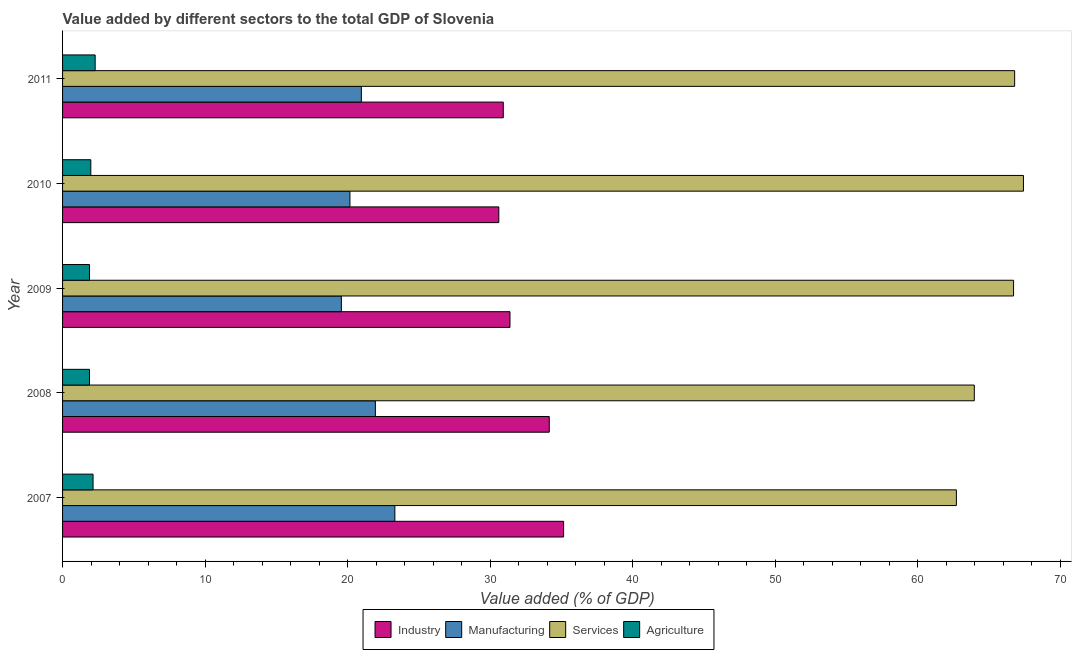How many different coloured bars are there?
Keep it short and to the point. 4. Are the number of bars per tick equal to the number of legend labels?
Your answer should be compact. Yes. Are the number of bars on each tick of the Y-axis equal?
Give a very brief answer. Yes. What is the label of the 4th group of bars from the top?
Ensure brevity in your answer.  2008. In how many cases, is the number of bars for a given year not equal to the number of legend labels?
Make the answer very short. 0. What is the value added by agricultural sector in 2007?
Offer a terse response. 2.14. Across all years, what is the maximum value added by industrial sector?
Your answer should be compact. 35.15. Across all years, what is the minimum value added by industrial sector?
Ensure brevity in your answer.  30.61. What is the total value added by manufacturing sector in the graph?
Keep it short and to the point. 105.94. What is the difference between the value added by agricultural sector in 2009 and that in 2011?
Make the answer very short. -0.39. What is the difference between the value added by industrial sector in 2008 and the value added by manufacturing sector in 2011?
Your response must be concise. 13.18. What is the average value added by manufacturing sector per year?
Offer a terse response. 21.19. In the year 2007, what is the difference between the value added by manufacturing sector and value added by services sector?
Offer a terse response. -39.4. In how many years, is the value added by agricultural sector greater than 14 %?
Your answer should be very brief. 0. What is the ratio of the value added by agricultural sector in 2010 to that in 2011?
Provide a short and direct response. 0.87. Is the value added by manufacturing sector in 2007 less than that in 2008?
Provide a succinct answer. No. Is the difference between the value added by services sector in 2008 and 2010 greater than the difference between the value added by industrial sector in 2008 and 2010?
Make the answer very short. No. In how many years, is the value added by agricultural sector greater than the average value added by agricultural sector taken over all years?
Offer a terse response. 2. Is it the case that in every year, the sum of the value added by agricultural sector and value added by manufacturing sector is greater than the sum of value added by services sector and value added by industrial sector?
Your response must be concise. No. What does the 4th bar from the top in 2011 represents?
Make the answer very short. Industry. What does the 4th bar from the bottom in 2011 represents?
Provide a short and direct response. Agriculture. Is it the case that in every year, the sum of the value added by industrial sector and value added by manufacturing sector is greater than the value added by services sector?
Provide a short and direct response. No. How many bars are there?
Offer a very short reply. 20. Are all the bars in the graph horizontal?
Give a very brief answer. Yes. How many years are there in the graph?
Your response must be concise. 5. Does the graph contain grids?
Your answer should be very brief. No. Where does the legend appear in the graph?
Provide a succinct answer. Bottom center. What is the title of the graph?
Keep it short and to the point. Value added by different sectors to the total GDP of Slovenia. What is the label or title of the X-axis?
Offer a terse response. Value added (% of GDP). What is the label or title of the Y-axis?
Offer a terse response. Year. What is the Value added (% of GDP) in Industry in 2007?
Your answer should be very brief. 35.15. What is the Value added (% of GDP) in Manufacturing in 2007?
Ensure brevity in your answer.  23.31. What is the Value added (% of GDP) in Services in 2007?
Provide a succinct answer. 62.71. What is the Value added (% of GDP) of Agriculture in 2007?
Ensure brevity in your answer.  2.14. What is the Value added (% of GDP) in Industry in 2008?
Your answer should be very brief. 34.15. What is the Value added (% of GDP) in Manufacturing in 2008?
Provide a short and direct response. 21.95. What is the Value added (% of GDP) in Services in 2008?
Give a very brief answer. 63.96. What is the Value added (% of GDP) of Agriculture in 2008?
Offer a terse response. 1.89. What is the Value added (% of GDP) of Industry in 2009?
Provide a succinct answer. 31.39. What is the Value added (% of GDP) of Manufacturing in 2009?
Your response must be concise. 19.56. What is the Value added (% of GDP) in Services in 2009?
Your answer should be very brief. 66.72. What is the Value added (% of GDP) in Agriculture in 2009?
Your answer should be compact. 1.89. What is the Value added (% of GDP) in Industry in 2010?
Your response must be concise. 30.61. What is the Value added (% of GDP) of Manufacturing in 2010?
Provide a succinct answer. 20.16. What is the Value added (% of GDP) in Services in 2010?
Keep it short and to the point. 67.41. What is the Value added (% of GDP) in Agriculture in 2010?
Ensure brevity in your answer.  1.98. What is the Value added (% of GDP) in Industry in 2011?
Ensure brevity in your answer.  30.92. What is the Value added (% of GDP) in Manufacturing in 2011?
Ensure brevity in your answer.  20.96. What is the Value added (% of GDP) of Services in 2011?
Provide a succinct answer. 66.79. What is the Value added (% of GDP) of Agriculture in 2011?
Your answer should be compact. 2.29. Across all years, what is the maximum Value added (% of GDP) in Industry?
Your answer should be very brief. 35.15. Across all years, what is the maximum Value added (% of GDP) of Manufacturing?
Your answer should be compact. 23.31. Across all years, what is the maximum Value added (% of GDP) in Services?
Make the answer very short. 67.41. Across all years, what is the maximum Value added (% of GDP) of Agriculture?
Ensure brevity in your answer.  2.29. Across all years, what is the minimum Value added (% of GDP) of Industry?
Provide a succinct answer. 30.61. Across all years, what is the minimum Value added (% of GDP) of Manufacturing?
Offer a terse response. 19.56. Across all years, what is the minimum Value added (% of GDP) of Services?
Ensure brevity in your answer.  62.71. Across all years, what is the minimum Value added (% of GDP) in Agriculture?
Ensure brevity in your answer.  1.89. What is the total Value added (% of GDP) of Industry in the graph?
Your answer should be very brief. 162.21. What is the total Value added (% of GDP) of Manufacturing in the graph?
Provide a succinct answer. 105.94. What is the total Value added (% of GDP) of Services in the graph?
Your answer should be very brief. 327.6. What is the total Value added (% of GDP) in Agriculture in the graph?
Your answer should be very brief. 10.19. What is the difference between the Value added (% of GDP) of Manufacturing in 2007 and that in 2008?
Offer a very short reply. 1.37. What is the difference between the Value added (% of GDP) of Services in 2007 and that in 2008?
Offer a terse response. -1.26. What is the difference between the Value added (% of GDP) of Agriculture in 2007 and that in 2008?
Offer a terse response. 0.25. What is the difference between the Value added (% of GDP) of Industry in 2007 and that in 2009?
Your answer should be very brief. 3.76. What is the difference between the Value added (% of GDP) of Manufacturing in 2007 and that in 2009?
Your answer should be very brief. 3.75. What is the difference between the Value added (% of GDP) in Services in 2007 and that in 2009?
Your response must be concise. -4.01. What is the difference between the Value added (% of GDP) in Agriculture in 2007 and that in 2009?
Offer a very short reply. 0.25. What is the difference between the Value added (% of GDP) in Industry in 2007 and that in 2010?
Ensure brevity in your answer.  4.55. What is the difference between the Value added (% of GDP) of Manufacturing in 2007 and that in 2010?
Offer a very short reply. 3.15. What is the difference between the Value added (% of GDP) of Services in 2007 and that in 2010?
Offer a very short reply. -4.7. What is the difference between the Value added (% of GDP) in Agriculture in 2007 and that in 2010?
Your answer should be very brief. 0.16. What is the difference between the Value added (% of GDP) of Industry in 2007 and that in 2011?
Your answer should be very brief. 4.23. What is the difference between the Value added (% of GDP) in Manufacturing in 2007 and that in 2011?
Keep it short and to the point. 2.35. What is the difference between the Value added (% of GDP) of Services in 2007 and that in 2011?
Ensure brevity in your answer.  -4.09. What is the difference between the Value added (% of GDP) in Agriculture in 2007 and that in 2011?
Your answer should be very brief. -0.15. What is the difference between the Value added (% of GDP) in Industry in 2008 and that in 2009?
Your answer should be very brief. 2.76. What is the difference between the Value added (% of GDP) of Manufacturing in 2008 and that in 2009?
Give a very brief answer. 2.39. What is the difference between the Value added (% of GDP) of Services in 2008 and that in 2009?
Offer a very short reply. -2.75. What is the difference between the Value added (% of GDP) of Agriculture in 2008 and that in 2009?
Your answer should be compact. -0. What is the difference between the Value added (% of GDP) in Industry in 2008 and that in 2010?
Your answer should be very brief. 3.54. What is the difference between the Value added (% of GDP) of Manufacturing in 2008 and that in 2010?
Provide a succinct answer. 1.78. What is the difference between the Value added (% of GDP) in Services in 2008 and that in 2010?
Give a very brief answer. -3.45. What is the difference between the Value added (% of GDP) of Agriculture in 2008 and that in 2010?
Give a very brief answer. -0.09. What is the difference between the Value added (% of GDP) in Industry in 2008 and that in 2011?
Your response must be concise. 3.23. What is the difference between the Value added (% of GDP) of Manufacturing in 2008 and that in 2011?
Ensure brevity in your answer.  0.98. What is the difference between the Value added (% of GDP) in Services in 2008 and that in 2011?
Give a very brief answer. -2.83. What is the difference between the Value added (% of GDP) in Agriculture in 2008 and that in 2011?
Your answer should be compact. -0.4. What is the difference between the Value added (% of GDP) in Industry in 2009 and that in 2010?
Keep it short and to the point. 0.78. What is the difference between the Value added (% of GDP) in Manufacturing in 2009 and that in 2010?
Provide a short and direct response. -0.6. What is the difference between the Value added (% of GDP) in Services in 2009 and that in 2010?
Ensure brevity in your answer.  -0.69. What is the difference between the Value added (% of GDP) of Agriculture in 2009 and that in 2010?
Ensure brevity in your answer.  -0.09. What is the difference between the Value added (% of GDP) in Industry in 2009 and that in 2011?
Offer a very short reply. 0.47. What is the difference between the Value added (% of GDP) in Manufacturing in 2009 and that in 2011?
Make the answer very short. -1.4. What is the difference between the Value added (% of GDP) of Services in 2009 and that in 2011?
Your answer should be compact. -0.08. What is the difference between the Value added (% of GDP) of Agriculture in 2009 and that in 2011?
Your answer should be compact. -0.39. What is the difference between the Value added (% of GDP) in Industry in 2010 and that in 2011?
Your answer should be compact. -0.31. What is the difference between the Value added (% of GDP) in Manufacturing in 2010 and that in 2011?
Offer a very short reply. -0.8. What is the difference between the Value added (% of GDP) in Services in 2010 and that in 2011?
Your answer should be very brief. 0.62. What is the difference between the Value added (% of GDP) of Agriculture in 2010 and that in 2011?
Your answer should be very brief. -0.3. What is the difference between the Value added (% of GDP) of Industry in 2007 and the Value added (% of GDP) of Manufacturing in 2008?
Your response must be concise. 13.21. What is the difference between the Value added (% of GDP) of Industry in 2007 and the Value added (% of GDP) of Services in 2008?
Make the answer very short. -28.81. What is the difference between the Value added (% of GDP) in Industry in 2007 and the Value added (% of GDP) in Agriculture in 2008?
Keep it short and to the point. 33.26. What is the difference between the Value added (% of GDP) of Manufacturing in 2007 and the Value added (% of GDP) of Services in 2008?
Offer a very short reply. -40.65. What is the difference between the Value added (% of GDP) in Manufacturing in 2007 and the Value added (% of GDP) in Agriculture in 2008?
Ensure brevity in your answer.  21.42. What is the difference between the Value added (% of GDP) in Services in 2007 and the Value added (% of GDP) in Agriculture in 2008?
Offer a terse response. 60.82. What is the difference between the Value added (% of GDP) in Industry in 2007 and the Value added (% of GDP) in Manufacturing in 2009?
Make the answer very short. 15.59. What is the difference between the Value added (% of GDP) in Industry in 2007 and the Value added (% of GDP) in Services in 2009?
Your response must be concise. -31.57. What is the difference between the Value added (% of GDP) in Industry in 2007 and the Value added (% of GDP) in Agriculture in 2009?
Make the answer very short. 33.26. What is the difference between the Value added (% of GDP) of Manufacturing in 2007 and the Value added (% of GDP) of Services in 2009?
Offer a very short reply. -43.41. What is the difference between the Value added (% of GDP) in Manufacturing in 2007 and the Value added (% of GDP) in Agriculture in 2009?
Offer a terse response. 21.42. What is the difference between the Value added (% of GDP) in Services in 2007 and the Value added (% of GDP) in Agriculture in 2009?
Offer a very short reply. 60.82. What is the difference between the Value added (% of GDP) of Industry in 2007 and the Value added (% of GDP) of Manufacturing in 2010?
Provide a short and direct response. 14.99. What is the difference between the Value added (% of GDP) in Industry in 2007 and the Value added (% of GDP) in Services in 2010?
Offer a terse response. -32.26. What is the difference between the Value added (% of GDP) of Industry in 2007 and the Value added (% of GDP) of Agriculture in 2010?
Offer a very short reply. 33.17. What is the difference between the Value added (% of GDP) in Manufacturing in 2007 and the Value added (% of GDP) in Services in 2010?
Your response must be concise. -44.1. What is the difference between the Value added (% of GDP) in Manufacturing in 2007 and the Value added (% of GDP) in Agriculture in 2010?
Provide a succinct answer. 21.33. What is the difference between the Value added (% of GDP) in Services in 2007 and the Value added (% of GDP) in Agriculture in 2010?
Offer a very short reply. 60.73. What is the difference between the Value added (% of GDP) in Industry in 2007 and the Value added (% of GDP) in Manufacturing in 2011?
Offer a terse response. 14.19. What is the difference between the Value added (% of GDP) of Industry in 2007 and the Value added (% of GDP) of Services in 2011?
Keep it short and to the point. -31.64. What is the difference between the Value added (% of GDP) in Industry in 2007 and the Value added (% of GDP) in Agriculture in 2011?
Your response must be concise. 32.87. What is the difference between the Value added (% of GDP) of Manufacturing in 2007 and the Value added (% of GDP) of Services in 2011?
Make the answer very short. -43.48. What is the difference between the Value added (% of GDP) of Manufacturing in 2007 and the Value added (% of GDP) of Agriculture in 2011?
Keep it short and to the point. 21.03. What is the difference between the Value added (% of GDP) in Services in 2007 and the Value added (% of GDP) in Agriculture in 2011?
Keep it short and to the point. 60.42. What is the difference between the Value added (% of GDP) in Industry in 2008 and the Value added (% of GDP) in Manufacturing in 2009?
Give a very brief answer. 14.59. What is the difference between the Value added (% of GDP) in Industry in 2008 and the Value added (% of GDP) in Services in 2009?
Your answer should be very brief. -32.57. What is the difference between the Value added (% of GDP) of Industry in 2008 and the Value added (% of GDP) of Agriculture in 2009?
Provide a succinct answer. 32.25. What is the difference between the Value added (% of GDP) in Manufacturing in 2008 and the Value added (% of GDP) in Services in 2009?
Provide a short and direct response. -44.77. What is the difference between the Value added (% of GDP) in Manufacturing in 2008 and the Value added (% of GDP) in Agriculture in 2009?
Keep it short and to the point. 20.05. What is the difference between the Value added (% of GDP) in Services in 2008 and the Value added (% of GDP) in Agriculture in 2009?
Keep it short and to the point. 62.07. What is the difference between the Value added (% of GDP) of Industry in 2008 and the Value added (% of GDP) of Manufacturing in 2010?
Offer a very short reply. 13.98. What is the difference between the Value added (% of GDP) of Industry in 2008 and the Value added (% of GDP) of Services in 2010?
Your answer should be compact. -33.27. What is the difference between the Value added (% of GDP) of Industry in 2008 and the Value added (% of GDP) of Agriculture in 2010?
Provide a short and direct response. 32.16. What is the difference between the Value added (% of GDP) of Manufacturing in 2008 and the Value added (% of GDP) of Services in 2010?
Keep it short and to the point. -45.47. What is the difference between the Value added (% of GDP) in Manufacturing in 2008 and the Value added (% of GDP) in Agriculture in 2010?
Provide a short and direct response. 19.96. What is the difference between the Value added (% of GDP) in Services in 2008 and the Value added (% of GDP) in Agriculture in 2010?
Ensure brevity in your answer.  61.98. What is the difference between the Value added (% of GDP) of Industry in 2008 and the Value added (% of GDP) of Manufacturing in 2011?
Offer a very short reply. 13.18. What is the difference between the Value added (% of GDP) of Industry in 2008 and the Value added (% of GDP) of Services in 2011?
Offer a terse response. -32.65. What is the difference between the Value added (% of GDP) of Industry in 2008 and the Value added (% of GDP) of Agriculture in 2011?
Your answer should be compact. 31.86. What is the difference between the Value added (% of GDP) of Manufacturing in 2008 and the Value added (% of GDP) of Services in 2011?
Keep it short and to the point. -44.85. What is the difference between the Value added (% of GDP) of Manufacturing in 2008 and the Value added (% of GDP) of Agriculture in 2011?
Offer a terse response. 19.66. What is the difference between the Value added (% of GDP) in Services in 2008 and the Value added (% of GDP) in Agriculture in 2011?
Offer a very short reply. 61.68. What is the difference between the Value added (% of GDP) of Industry in 2009 and the Value added (% of GDP) of Manufacturing in 2010?
Provide a succinct answer. 11.23. What is the difference between the Value added (% of GDP) in Industry in 2009 and the Value added (% of GDP) in Services in 2010?
Offer a very short reply. -36.02. What is the difference between the Value added (% of GDP) in Industry in 2009 and the Value added (% of GDP) in Agriculture in 2010?
Make the answer very short. 29.41. What is the difference between the Value added (% of GDP) in Manufacturing in 2009 and the Value added (% of GDP) in Services in 2010?
Your answer should be compact. -47.85. What is the difference between the Value added (% of GDP) of Manufacturing in 2009 and the Value added (% of GDP) of Agriculture in 2010?
Offer a terse response. 17.58. What is the difference between the Value added (% of GDP) of Services in 2009 and the Value added (% of GDP) of Agriculture in 2010?
Offer a terse response. 64.74. What is the difference between the Value added (% of GDP) of Industry in 2009 and the Value added (% of GDP) of Manufacturing in 2011?
Provide a succinct answer. 10.43. What is the difference between the Value added (% of GDP) of Industry in 2009 and the Value added (% of GDP) of Services in 2011?
Your answer should be very brief. -35.41. What is the difference between the Value added (% of GDP) in Industry in 2009 and the Value added (% of GDP) in Agriculture in 2011?
Give a very brief answer. 29.1. What is the difference between the Value added (% of GDP) of Manufacturing in 2009 and the Value added (% of GDP) of Services in 2011?
Provide a short and direct response. -47.23. What is the difference between the Value added (% of GDP) of Manufacturing in 2009 and the Value added (% of GDP) of Agriculture in 2011?
Your answer should be very brief. 17.27. What is the difference between the Value added (% of GDP) of Services in 2009 and the Value added (% of GDP) of Agriculture in 2011?
Provide a short and direct response. 64.43. What is the difference between the Value added (% of GDP) in Industry in 2010 and the Value added (% of GDP) in Manufacturing in 2011?
Provide a short and direct response. 9.64. What is the difference between the Value added (% of GDP) of Industry in 2010 and the Value added (% of GDP) of Services in 2011?
Give a very brief answer. -36.19. What is the difference between the Value added (% of GDP) in Industry in 2010 and the Value added (% of GDP) in Agriculture in 2011?
Your answer should be very brief. 28.32. What is the difference between the Value added (% of GDP) of Manufacturing in 2010 and the Value added (% of GDP) of Services in 2011?
Offer a terse response. -46.63. What is the difference between the Value added (% of GDP) of Manufacturing in 2010 and the Value added (% of GDP) of Agriculture in 2011?
Your response must be concise. 17.87. What is the difference between the Value added (% of GDP) of Services in 2010 and the Value added (% of GDP) of Agriculture in 2011?
Your answer should be very brief. 65.13. What is the average Value added (% of GDP) in Industry per year?
Provide a succinct answer. 32.44. What is the average Value added (% of GDP) of Manufacturing per year?
Your answer should be very brief. 21.19. What is the average Value added (% of GDP) of Services per year?
Your answer should be compact. 65.52. What is the average Value added (% of GDP) in Agriculture per year?
Keep it short and to the point. 2.04. In the year 2007, what is the difference between the Value added (% of GDP) of Industry and Value added (% of GDP) of Manufacturing?
Provide a short and direct response. 11.84. In the year 2007, what is the difference between the Value added (% of GDP) of Industry and Value added (% of GDP) of Services?
Provide a succinct answer. -27.56. In the year 2007, what is the difference between the Value added (% of GDP) of Industry and Value added (% of GDP) of Agriculture?
Provide a short and direct response. 33.01. In the year 2007, what is the difference between the Value added (% of GDP) of Manufacturing and Value added (% of GDP) of Services?
Your response must be concise. -39.4. In the year 2007, what is the difference between the Value added (% of GDP) of Manufacturing and Value added (% of GDP) of Agriculture?
Your answer should be compact. 21.17. In the year 2007, what is the difference between the Value added (% of GDP) of Services and Value added (% of GDP) of Agriculture?
Keep it short and to the point. 60.57. In the year 2008, what is the difference between the Value added (% of GDP) of Industry and Value added (% of GDP) of Manufacturing?
Keep it short and to the point. 12.2. In the year 2008, what is the difference between the Value added (% of GDP) in Industry and Value added (% of GDP) in Services?
Make the answer very short. -29.82. In the year 2008, what is the difference between the Value added (% of GDP) in Industry and Value added (% of GDP) in Agriculture?
Provide a succinct answer. 32.26. In the year 2008, what is the difference between the Value added (% of GDP) in Manufacturing and Value added (% of GDP) in Services?
Provide a succinct answer. -42.02. In the year 2008, what is the difference between the Value added (% of GDP) in Manufacturing and Value added (% of GDP) in Agriculture?
Keep it short and to the point. 20.06. In the year 2008, what is the difference between the Value added (% of GDP) of Services and Value added (% of GDP) of Agriculture?
Your response must be concise. 62.07. In the year 2009, what is the difference between the Value added (% of GDP) of Industry and Value added (% of GDP) of Manufacturing?
Your response must be concise. 11.83. In the year 2009, what is the difference between the Value added (% of GDP) of Industry and Value added (% of GDP) of Services?
Ensure brevity in your answer.  -35.33. In the year 2009, what is the difference between the Value added (% of GDP) of Industry and Value added (% of GDP) of Agriculture?
Keep it short and to the point. 29.5. In the year 2009, what is the difference between the Value added (% of GDP) in Manufacturing and Value added (% of GDP) in Services?
Give a very brief answer. -47.16. In the year 2009, what is the difference between the Value added (% of GDP) of Manufacturing and Value added (% of GDP) of Agriculture?
Your answer should be very brief. 17.67. In the year 2009, what is the difference between the Value added (% of GDP) of Services and Value added (% of GDP) of Agriculture?
Keep it short and to the point. 64.83. In the year 2010, what is the difference between the Value added (% of GDP) of Industry and Value added (% of GDP) of Manufacturing?
Your answer should be very brief. 10.44. In the year 2010, what is the difference between the Value added (% of GDP) in Industry and Value added (% of GDP) in Services?
Your response must be concise. -36.81. In the year 2010, what is the difference between the Value added (% of GDP) of Industry and Value added (% of GDP) of Agriculture?
Provide a succinct answer. 28.62. In the year 2010, what is the difference between the Value added (% of GDP) in Manufacturing and Value added (% of GDP) in Services?
Your answer should be very brief. -47.25. In the year 2010, what is the difference between the Value added (% of GDP) in Manufacturing and Value added (% of GDP) in Agriculture?
Your answer should be very brief. 18.18. In the year 2010, what is the difference between the Value added (% of GDP) in Services and Value added (% of GDP) in Agriculture?
Provide a short and direct response. 65.43. In the year 2011, what is the difference between the Value added (% of GDP) in Industry and Value added (% of GDP) in Manufacturing?
Provide a short and direct response. 9.96. In the year 2011, what is the difference between the Value added (% of GDP) of Industry and Value added (% of GDP) of Services?
Offer a terse response. -35.87. In the year 2011, what is the difference between the Value added (% of GDP) of Industry and Value added (% of GDP) of Agriculture?
Your answer should be very brief. 28.63. In the year 2011, what is the difference between the Value added (% of GDP) in Manufacturing and Value added (% of GDP) in Services?
Ensure brevity in your answer.  -45.83. In the year 2011, what is the difference between the Value added (% of GDP) in Manufacturing and Value added (% of GDP) in Agriculture?
Your answer should be compact. 18.68. In the year 2011, what is the difference between the Value added (% of GDP) in Services and Value added (% of GDP) in Agriculture?
Give a very brief answer. 64.51. What is the ratio of the Value added (% of GDP) of Industry in 2007 to that in 2008?
Your response must be concise. 1.03. What is the ratio of the Value added (% of GDP) in Manufacturing in 2007 to that in 2008?
Ensure brevity in your answer.  1.06. What is the ratio of the Value added (% of GDP) in Services in 2007 to that in 2008?
Keep it short and to the point. 0.98. What is the ratio of the Value added (% of GDP) in Agriculture in 2007 to that in 2008?
Ensure brevity in your answer.  1.13. What is the ratio of the Value added (% of GDP) in Industry in 2007 to that in 2009?
Provide a short and direct response. 1.12. What is the ratio of the Value added (% of GDP) in Manufacturing in 2007 to that in 2009?
Provide a short and direct response. 1.19. What is the ratio of the Value added (% of GDP) in Services in 2007 to that in 2009?
Your response must be concise. 0.94. What is the ratio of the Value added (% of GDP) in Agriculture in 2007 to that in 2009?
Your answer should be compact. 1.13. What is the ratio of the Value added (% of GDP) in Industry in 2007 to that in 2010?
Provide a short and direct response. 1.15. What is the ratio of the Value added (% of GDP) of Manufacturing in 2007 to that in 2010?
Make the answer very short. 1.16. What is the ratio of the Value added (% of GDP) of Services in 2007 to that in 2010?
Provide a short and direct response. 0.93. What is the ratio of the Value added (% of GDP) of Agriculture in 2007 to that in 2010?
Your response must be concise. 1.08. What is the ratio of the Value added (% of GDP) of Industry in 2007 to that in 2011?
Ensure brevity in your answer.  1.14. What is the ratio of the Value added (% of GDP) in Manufacturing in 2007 to that in 2011?
Give a very brief answer. 1.11. What is the ratio of the Value added (% of GDP) in Services in 2007 to that in 2011?
Your answer should be very brief. 0.94. What is the ratio of the Value added (% of GDP) of Agriculture in 2007 to that in 2011?
Offer a very short reply. 0.94. What is the ratio of the Value added (% of GDP) in Industry in 2008 to that in 2009?
Make the answer very short. 1.09. What is the ratio of the Value added (% of GDP) of Manufacturing in 2008 to that in 2009?
Give a very brief answer. 1.12. What is the ratio of the Value added (% of GDP) of Services in 2008 to that in 2009?
Your response must be concise. 0.96. What is the ratio of the Value added (% of GDP) of Industry in 2008 to that in 2010?
Offer a terse response. 1.12. What is the ratio of the Value added (% of GDP) of Manufacturing in 2008 to that in 2010?
Your response must be concise. 1.09. What is the ratio of the Value added (% of GDP) of Services in 2008 to that in 2010?
Your answer should be compact. 0.95. What is the ratio of the Value added (% of GDP) of Agriculture in 2008 to that in 2010?
Ensure brevity in your answer.  0.95. What is the ratio of the Value added (% of GDP) in Industry in 2008 to that in 2011?
Offer a terse response. 1.1. What is the ratio of the Value added (% of GDP) of Manufacturing in 2008 to that in 2011?
Provide a succinct answer. 1.05. What is the ratio of the Value added (% of GDP) in Services in 2008 to that in 2011?
Make the answer very short. 0.96. What is the ratio of the Value added (% of GDP) in Agriculture in 2008 to that in 2011?
Your response must be concise. 0.83. What is the ratio of the Value added (% of GDP) of Industry in 2009 to that in 2010?
Your answer should be very brief. 1.03. What is the ratio of the Value added (% of GDP) of Manufacturing in 2009 to that in 2010?
Make the answer very short. 0.97. What is the ratio of the Value added (% of GDP) of Agriculture in 2009 to that in 2010?
Keep it short and to the point. 0.95. What is the ratio of the Value added (% of GDP) in Industry in 2009 to that in 2011?
Offer a terse response. 1.02. What is the ratio of the Value added (% of GDP) of Manufacturing in 2009 to that in 2011?
Offer a terse response. 0.93. What is the ratio of the Value added (% of GDP) in Services in 2009 to that in 2011?
Your answer should be very brief. 1. What is the ratio of the Value added (% of GDP) of Agriculture in 2009 to that in 2011?
Provide a short and direct response. 0.83. What is the ratio of the Value added (% of GDP) of Manufacturing in 2010 to that in 2011?
Give a very brief answer. 0.96. What is the ratio of the Value added (% of GDP) in Services in 2010 to that in 2011?
Provide a short and direct response. 1.01. What is the ratio of the Value added (% of GDP) of Agriculture in 2010 to that in 2011?
Offer a terse response. 0.87. What is the difference between the highest and the second highest Value added (% of GDP) in Manufacturing?
Keep it short and to the point. 1.37. What is the difference between the highest and the second highest Value added (% of GDP) in Services?
Your answer should be very brief. 0.62. What is the difference between the highest and the second highest Value added (% of GDP) in Agriculture?
Offer a terse response. 0.15. What is the difference between the highest and the lowest Value added (% of GDP) of Industry?
Make the answer very short. 4.55. What is the difference between the highest and the lowest Value added (% of GDP) in Manufacturing?
Provide a succinct answer. 3.75. What is the difference between the highest and the lowest Value added (% of GDP) in Services?
Provide a short and direct response. 4.7. What is the difference between the highest and the lowest Value added (% of GDP) of Agriculture?
Ensure brevity in your answer.  0.4. 